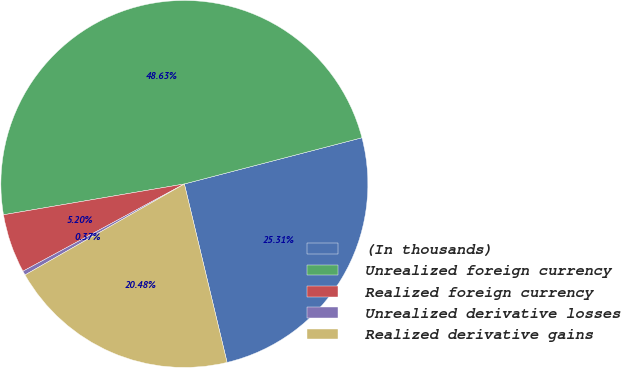Convert chart. <chart><loc_0><loc_0><loc_500><loc_500><pie_chart><fcel>(In thousands)<fcel>Unrealized foreign currency<fcel>Realized foreign currency<fcel>Unrealized derivative losses<fcel>Realized derivative gains<nl><fcel>25.31%<fcel>48.63%<fcel>5.2%<fcel>0.37%<fcel>20.48%<nl></chart> 